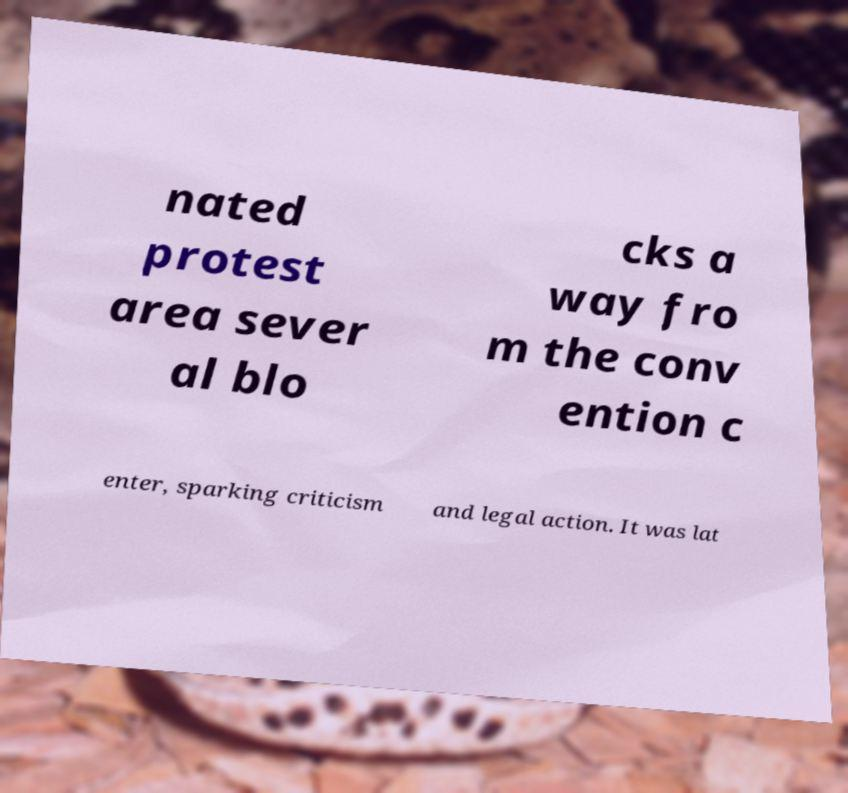There's text embedded in this image that I need extracted. Can you transcribe it verbatim? nated protest area sever al blo cks a way fro m the conv ention c enter, sparking criticism and legal action. It was lat 